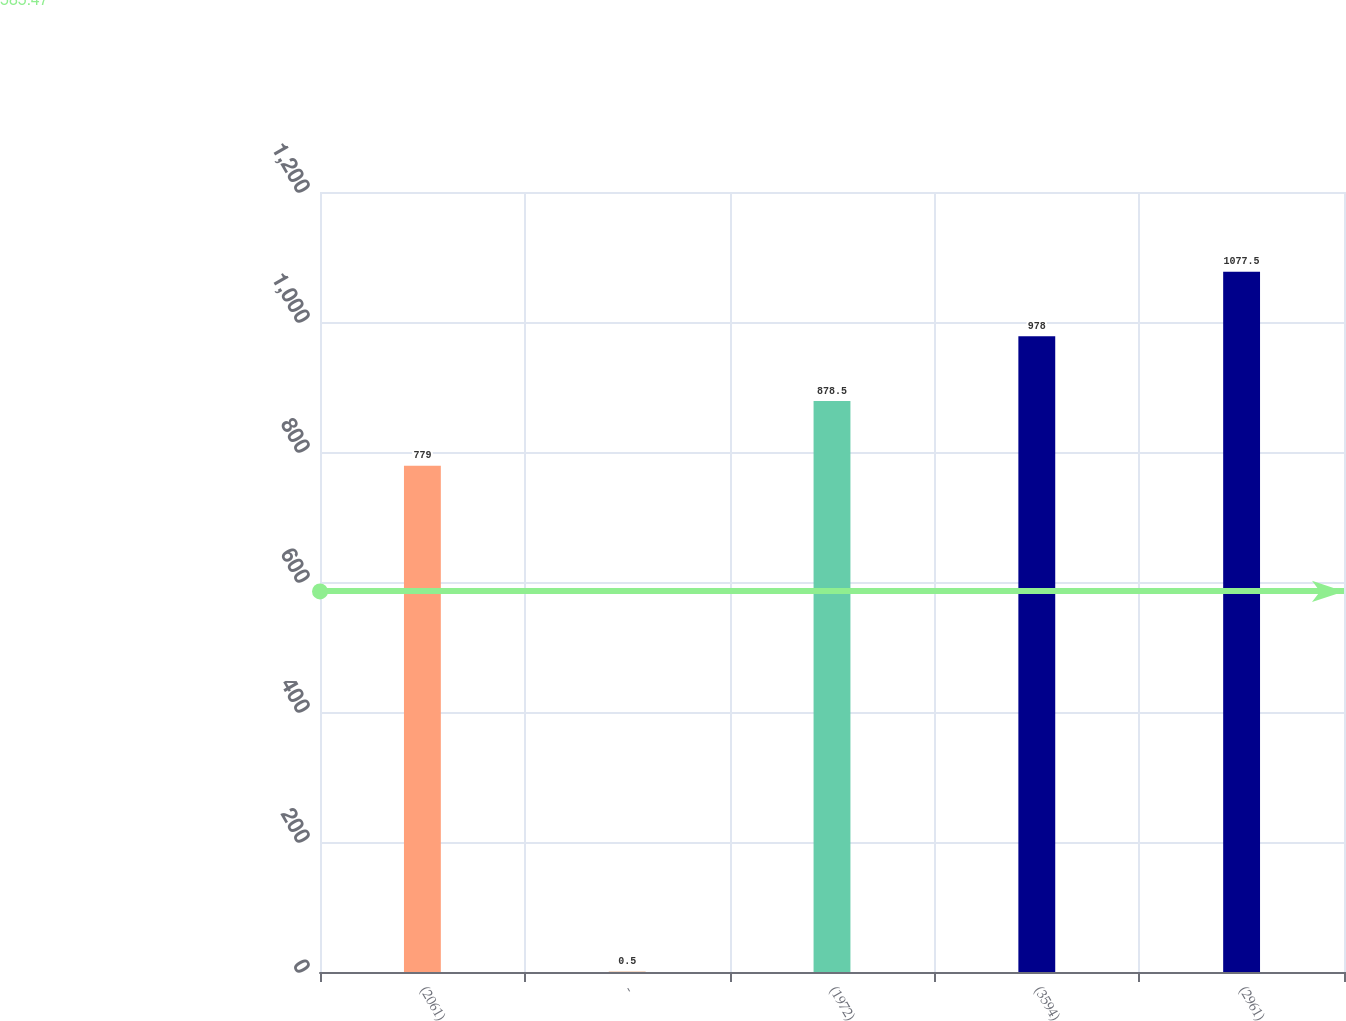Convert chart. <chart><loc_0><loc_0><loc_500><loc_500><bar_chart><fcel>(2061)<fcel>-<fcel>(1972)<fcel>(3594)<fcel>(2961)<nl><fcel>779<fcel>0.5<fcel>878.5<fcel>978<fcel>1077.5<nl></chart> 